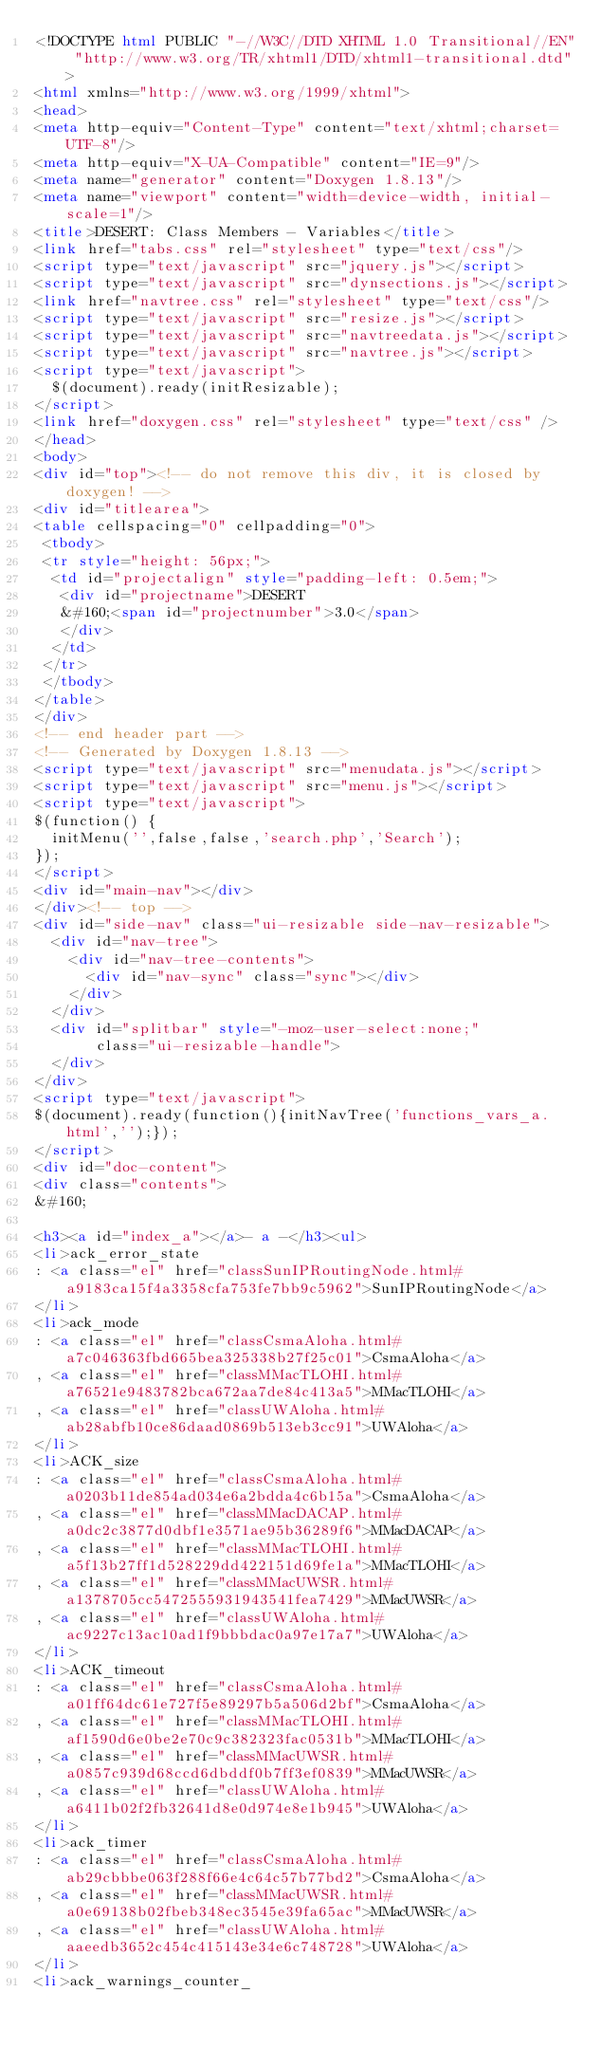Convert code to text. <code><loc_0><loc_0><loc_500><loc_500><_HTML_><!DOCTYPE html PUBLIC "-//W3C//DTD XHTML 1.0 Transitional//EN" "http://www.w3.org/TR/xhtml1/DTD/xhtml1-transitional.dtd">
<html xmlns="http://www.w3.org/1999/xhtml">
<head>
<meta http-equiv="Content-Type" content="text/xhtml;charset=UTF-8"/>
<meta http-equiv="X-UA-Compatible" content="IE=9"/>
<meta name="generator" content="Doxygen 1.8.13"/>
<meta name="viewport" content="width=device-width, initial-scale=1"/>
<title>DESERT: Class Members - Variables</title>
<link href="tabs.css" rel="stylesheet" type="text/css"/>
<script type="text/javascript" src="jquery.js"></script>
<script type="text/javascript" src="dynsections.js"></script>
<link href="navtree.css" rel="stylesheet" type="text/css"/>
<script type="text/javascript" src="resize.js"></script>
<script type="text/javascript" src="navtreedata.js"></script>
<script type="text/javascript" src="navtree.js"></script>
<script type="text/javascript">
  $(document).ready(initResizable);
</script>
<link href="doxygen.css" rel="stylesheet" type="text/css" />
</head>
<body>
<div id="top"><!-- do not remove this div, it is closed by doxygen! -->
<div id="titlearea">
<table cellspacing="0" cellpadding="0">
 <tbody>
 <tr style="height: 56px;">
  <td id="projectalign" style="padding-left: 0.5em;">
   <div id="projectname">DESERT
   &#160;<span id="projectnumber">3.0</span>
   </div>
  </td>
 </tr>
 </tbody>
</table>
</div>
<!-- end header part -->
<!-- Generated by Doxygen 1.8.13 -->
<script type="text/javascript" src="menudata.js"></script>
<script type="text/javascript" src="menu.js"></script>
<script type="text/javascript">
$(function() {
  initMenu('',false,false,'search.php','Search');
});
</script>
<div id="main-nav"></div>
</div><!-- top -->
<div id="side-nav" class="ui-resizable side-nav-resizable">
  <div id="nav-tree">
    <div id="nav-tree-contents">
      <div id="nav-sync" class="sync"></div>
    </div>
  </div>
  <div id="splitbar" style="-moz-user-select:none;" 
       class="ui-resizable-handle">
  </div>
</div>
<script type="text/javascript">
$(document).ready(function(){initNavTree('functions_vars_a.html','');});
</script>
<div id="doc-content">
<div class="contents">
&#160;

<h3><a id="index_a"></a>- a -</h3><ul>
<li>ack_error_state
: <a class="el" href="classSunIPRoutingNode.html#a9183ca15f4a3358cfa753fe7bb9c5962">SunIPRoutingNode</a>
</li>
<li>ack_mode
: <a class="el" href="classCsmaAloha.html#a7c046363fbd665bea325338b27f25c01">CsmaAloha</a>
, <a class="el" href="classMMacTLOHI.html#a76521e9483782bca672aa7de84c413a5">MMacTLOHI</a>
, <a class="el" href="classUWAloha.html#ab28abfb10ce86daad0869b513eb3cc91">UWAloha</a>
</li>
<li>ACK_size
: <a class="el" href="classCsmaAloha.html#a0203b11de854ad034e6a2bdda4c6b15a">CsmaAloha</a>
, <a class="el" href="classMMacDACAP.html#a0dc2c3877d0dbf1e3571ae95b36289f6">MMacDACAP</a>
, <a class="el" href="classMMacTLOHI.html#a5f13b27ff1d528229dd422151d69fe1a">MMacTLOHI</a>
, <a class="el" href="classMMacUWSR.html#a1378705cc5472555931943541fea7429">MMacUWSR</a>
, <a class="el" href="classUWAloha.html#ac9227c13ac10ad1f9bbbdac0a97e17a7">UWAloha</a>
</li>
<li>ACK_timeout
: <a class="el" href="classCsmaAloha.html#a01ff64dc61e727f5e89297b5a506d2bf">CsmaAloha</a>
, <a class="el" href="classMMacTLOHI.html#af1590d6e0be2e70c9c382323fac0531b">MMacTLOHI</a>
, <a class="el" href="classMMacUWSR.html#a0857c939d68ccd6dbddf0b7ff3ef0839">MMacUWSR</a>
, <a class="el" href="classUWAloha.html#a6411b02f2fb32641d8e0d974e8e1b945">UWAloha</a>
</li>
<li>ack_timer
: <a class="el" href="classCsmaAloha.html#ab29cbbbe063f288f66e4c64c57b77bd2">CsmaAloha</a>
, <a class="el" href="classMMacUWSR.html#a0e69138b02fbeb348ec3545e39fa65ac">MMacUWSR</a>
, <a class="el" href="classUWAloha.html#aaeedb3652c454c415143e34e6c748728">UWAloha</a>
</li>
<li>ack_warnings_counter_</code> 